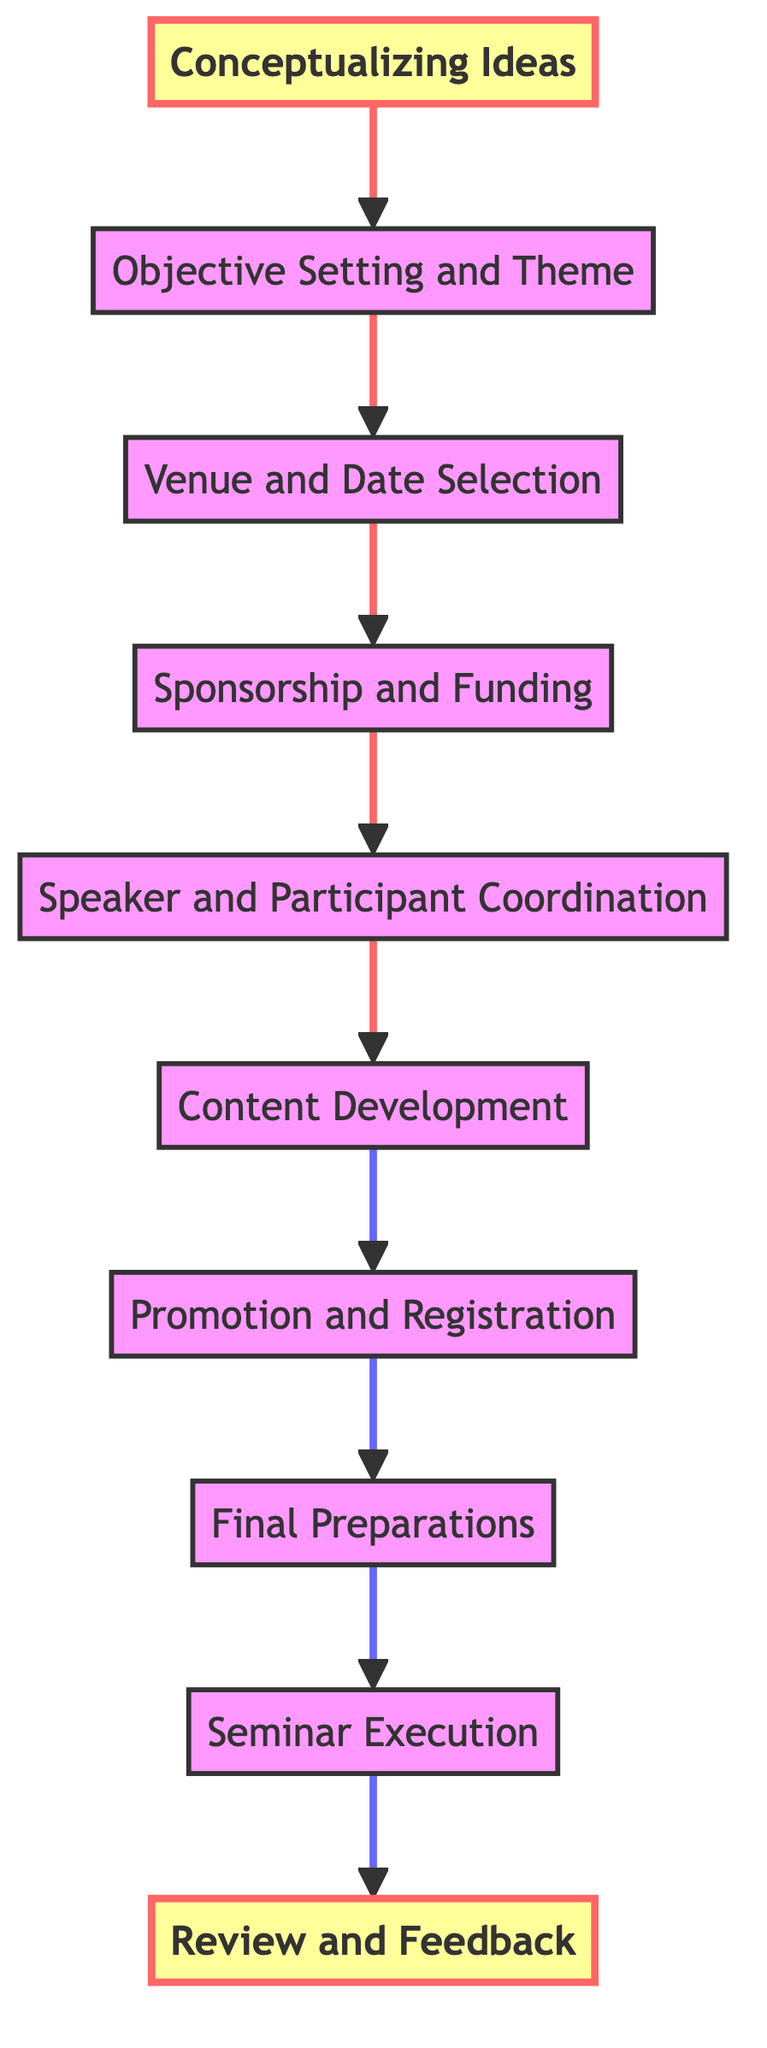What is the first step in organizing the seminar? The diagram shows that the first step is "Conceptualizing Ideas". This is identified as the starting node in the flow chart, which leads to the next step.
Answer: Conceptualizing Ideas What is the last step in the seminar organization process? According to the flow chart, the last step is "Review and Feedback". This is the final node that follows all the preceding steps.
Answer: Review and Feedback How many nodes are there in total in the diagram? By counting the listed nodes in the flow chart, there are ten distinct steps from "Conceptualizing Ideas" to "Review and Feedback".
Answer: Ten What follows "Content Development" in the seminar organization process? The diagram indicates that after "Content Development", the next step is "Promotion and Registration". This shows the sequential flow of the process.
Answer: Promotion and Registration Which step involves securing financial support? The node named "Sponsorship and Funding" is specifically about securing financial support from various organizations. It directly addresses the need for financial resources.
Answer: Sponsorship and Funding Which two steps are directly connected? The step "Final Preparations" directly connects to "Seminar Execution", indicating that final checks and arrangements must be completed before the actual seminar takes place.
Answer: Final Preparations and Seminar Execution What is the relationship between "Venue and Date Selection" and "Sponsorship and Funding"? "Venue and Date Selection" must occur before "Sponsorship and Funding", as having a venue and date is likely necessary to approach potential sponsors for funding for specific arrangements.
Answer: Sequential relationship How many steps occur between "Objective Setting and Theme" and "Final Preparations"? Counting the nodes between "Objective Setting and Theme" and "Final Preparations", there are five steps: "Venue and Date Selection", "Sponsorship and Funding", "Speaker and Participant Coordination", "Content Development", and "Promotion and Registration".
Answer: Five What type of flow diagram is this? This is a flow chart of an instruction that flows from bottom to top, detailing the sequential steps required for organizing an international seminar.
Answer: Instruction Flow Chart 